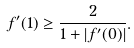<formula> <loc_0><loc_0><loc_500><loc_500>f ^ { \prime } ( 1 ) \geq \frac { 2 } { 1 + | f ^ { \prime } ( 0 ) | } .</formula> 